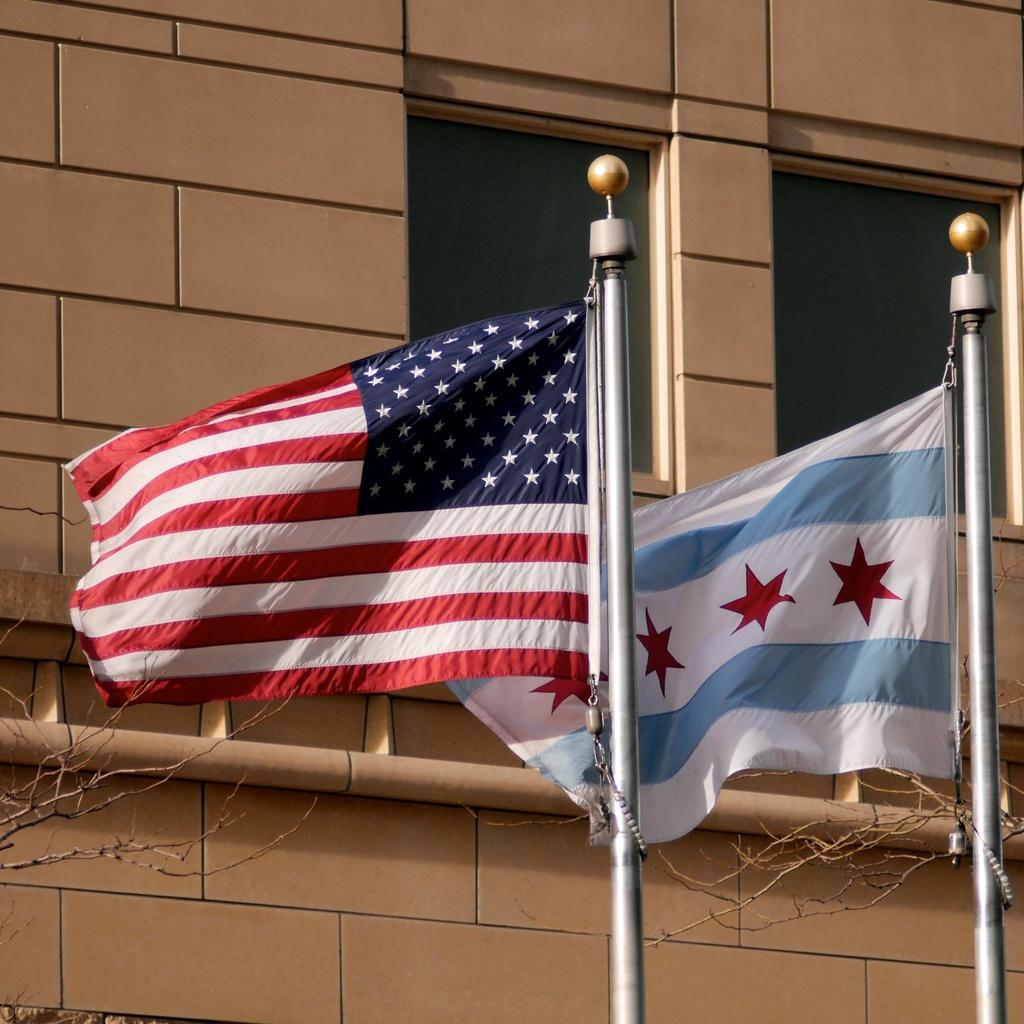What can be seen in the image that represents a symbol or country? There are flags in the image. What are the flags attached to in the image? There are poles in the image. What is the background of the image made of? There is a wall in the image. What allows light to enter the space in the image? There are windows in the image. What object is present that carries fluids or gases? There is a pipe in the image. What type of natural elements can be seen in the image? There are branches in the image. What type of agreement is being signed in the image? There is no indication of an agreement or signing in the image. What tin object can be seen on the wall in the image? There is no tin object present in the image. 